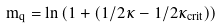<formula> <loc_0><loc_0><loc_500><loc_500>m _ { q } = \ln \left ( 1 + \left ( 1 / 2 \kappa - 1 / 2 \kappa _ { c r i t } \right ) \right )</formula> 